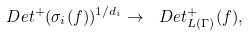<formula> <loc_0><loc_0><loc_500><loc_500>\ D e t ^ { + } ( \sigma _ { i } ( f ) ) ^ { 1 / d _ { i } } \to \ D e t _ { L ( \Gamma ) } ^ { + } ( f ) ,</formula> 